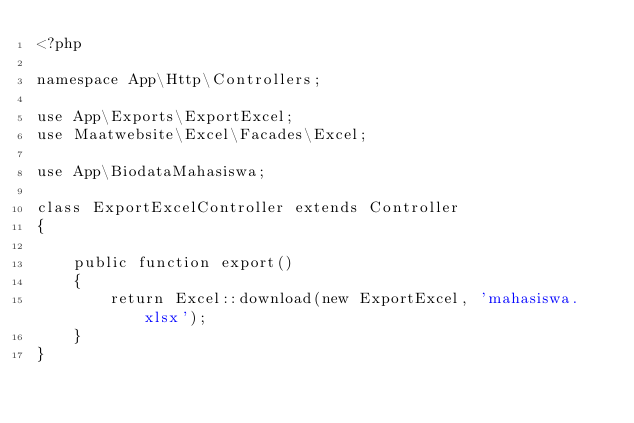Convert code to text. <code><loc_0><loc_0><loc_500><loc_500><_PHP_><?php

namespace App\Http\Controllers;

use App\Exports\ExportExcel;
use Maatwebsite\Excel\Facades\Excel;

use App\BiodataMahasiswa;

class ExportExcelController extends Controller
{

    public function export() 
    {
        return Excel::download(new ExportExcel, 'mahasiswa.xlsx');
    }
}
</code> 